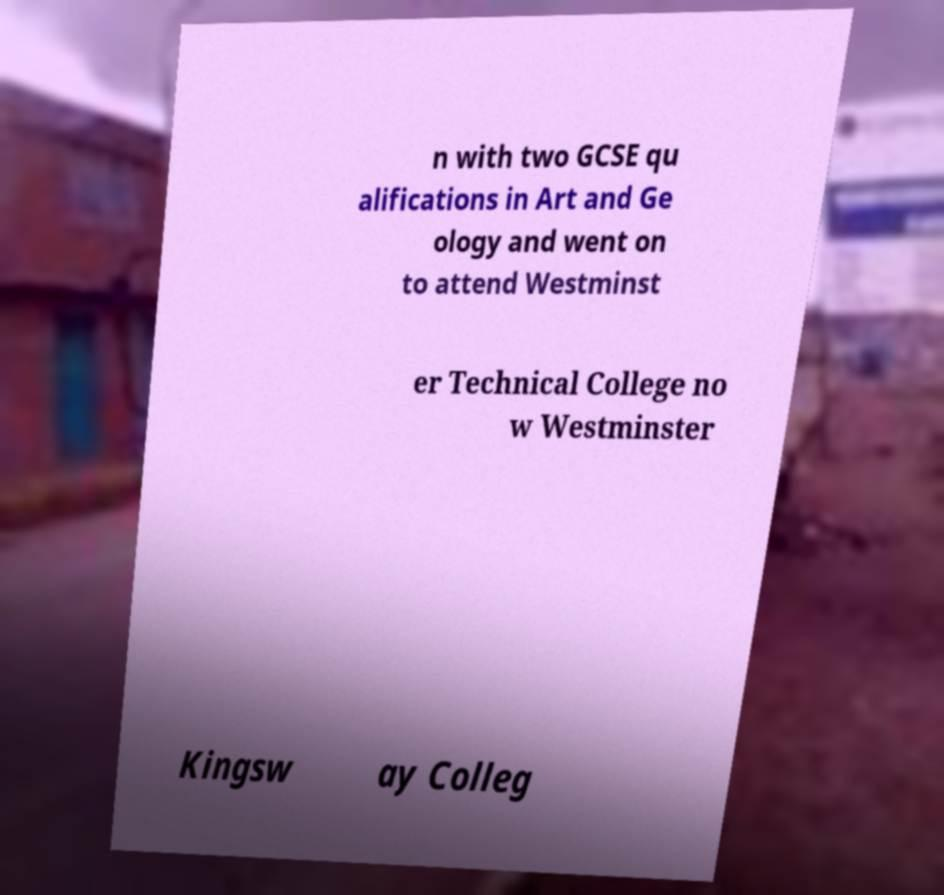Could you extract and type out the text from this image? n with two GCSE qu alifications in Art and Ge ology and went on to attend Westminst er Technical College no w Westminster Kingsw ay Colleg 